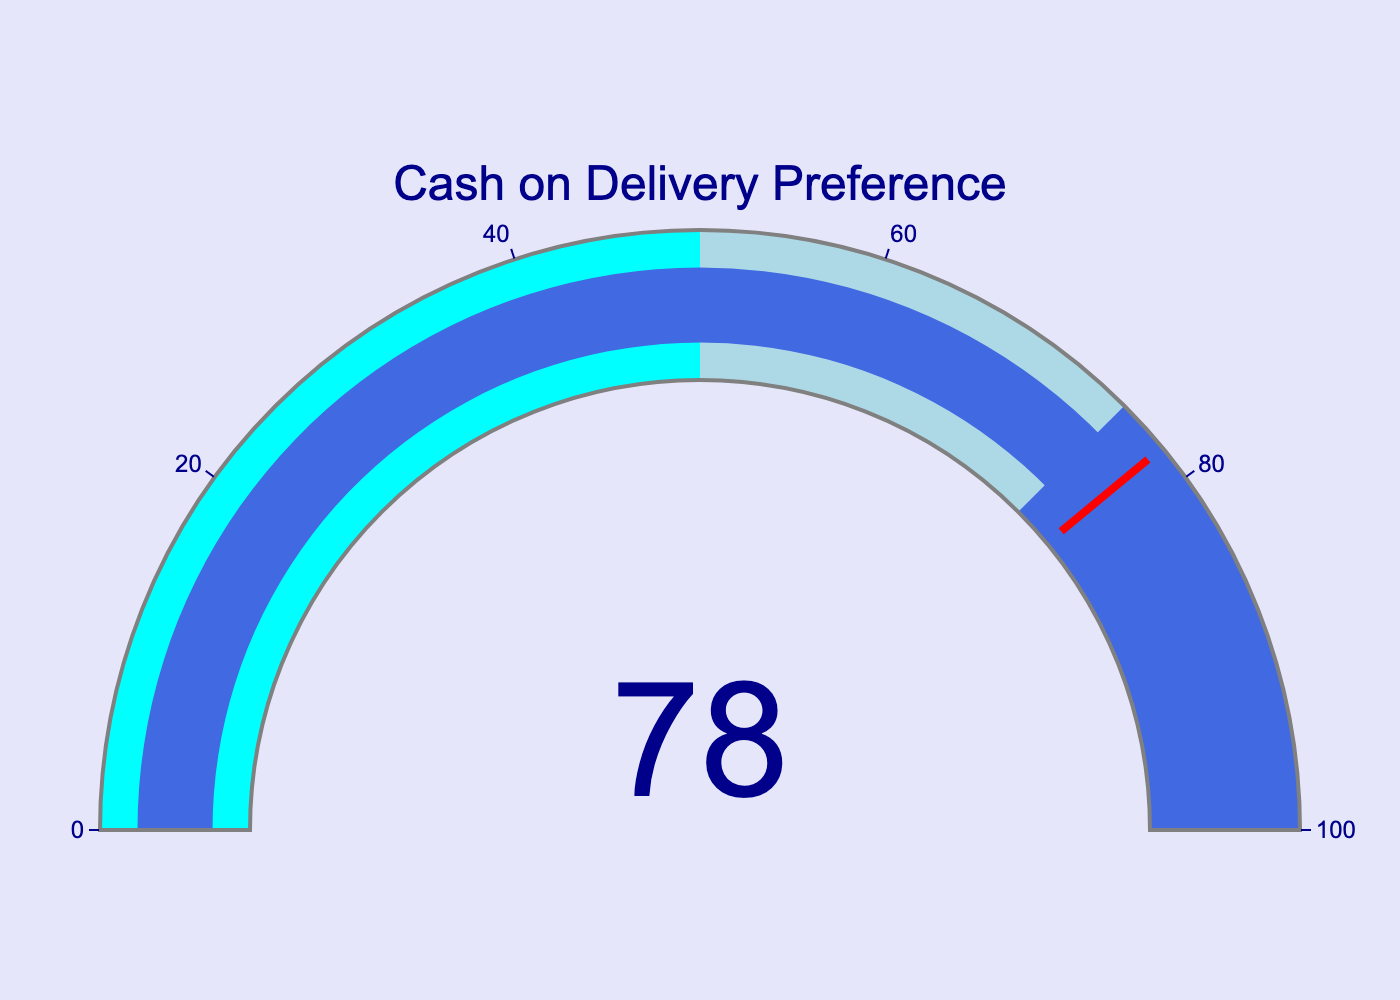What is the value shown in the gauge chart? The value shown on the gauge chart is indicated prominently in the center. This value represents the percentage of Kuchaman residents who prefer cash on delivery for online orders.
Answer: 78 What is the title of the gauge chart? The title of the gauge chart is displayed at the top of the figure. It provides an overview of what the gauge chart represents.
Answer: Cash on Delivery Preference Which color is used for the bar indicator in the gauge chart? The bar indicator's color is a specific shade that visually represents the value on the gauge chart.
Answer: Royal Blue What is the range of values on the axis of the gauge? The range of values on the gauge is shown along the axis, extending from the minimum to the maximum value it can represent.
Answer: 0 to 100 In which colored section does the value 78 fall? The gauge chart is divided into multiple colored sections; identifying the section where the indicated value falls helps understand its context.
Answer: Royal Blue Is the indicated value in the threshold range, and what color is used to highlight it? The gauge chart has a specific threshold that, if met or exceeded, gets highlighted with a particular color, depicted by a line.
Answer: Yes, Red How does the gauge chart visually differentiate values from 0-50, 50-75, and 75-100? The gauge chart has segments each colored differently to visually differentiate between these ranges. Identify the colors used for each range.
Answer: Cyan, Light Blue, Royal Blue What color is used for the background of the gauge chart? The background color of the gauge chart provides a backdrop and context for better readability.
Answer: White How much of the gauge chart is filled if the threshold value is at 78? The gauge chart shows filling till the threshold value which helps in understanding how much of the range is covered. Correlate with the filled colored sections.
Answer: 78% What would be the average of the value shown if similar gauge charts representing five different cities (each showing the same 78%) are considered? To find the average value, duplicate the current value across five instances and then calculate: (78 + 78 + 78 + 78 + 78) / 5.
Answer: 78 